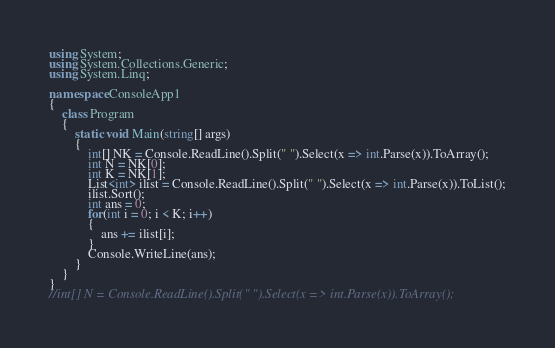Convert code to text. <code><loc_0><loc_0><loc_500><loc_500><_C#_>using System;
using System.Collections.Generic;
using System.Linq;

namespace ConsoleApp1
{
    class Program
    {
        static void Main(string[] args)
        {
            int[] NK = Console.ReadLine().Split(" ").Select(x => int.Parse(x)).ToArray();
            int N = NK[0];
            int K = NK[1];
            List<int> ilist = Console.ReadLine().Split(" ").Select(x => int.Parse(x)).ToList();
            ilist.Sort();
            int ans = 0;
            for(int i = 0; i < K; i++)
            {
                ans += ilist[i];
            }
            Console.WriteLine(ans);
        }
    }
}
//int[] N = Console.ReadLine().Split(" ").Select(x => int.Parse(x)).ToArray();</code> 